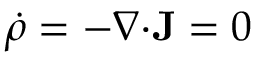Convert formula to latex. <formula><loc_0><loc_0><loc_500><loc_500>\dot { \rho } = - \nabla \cdot J = 0</formula> 